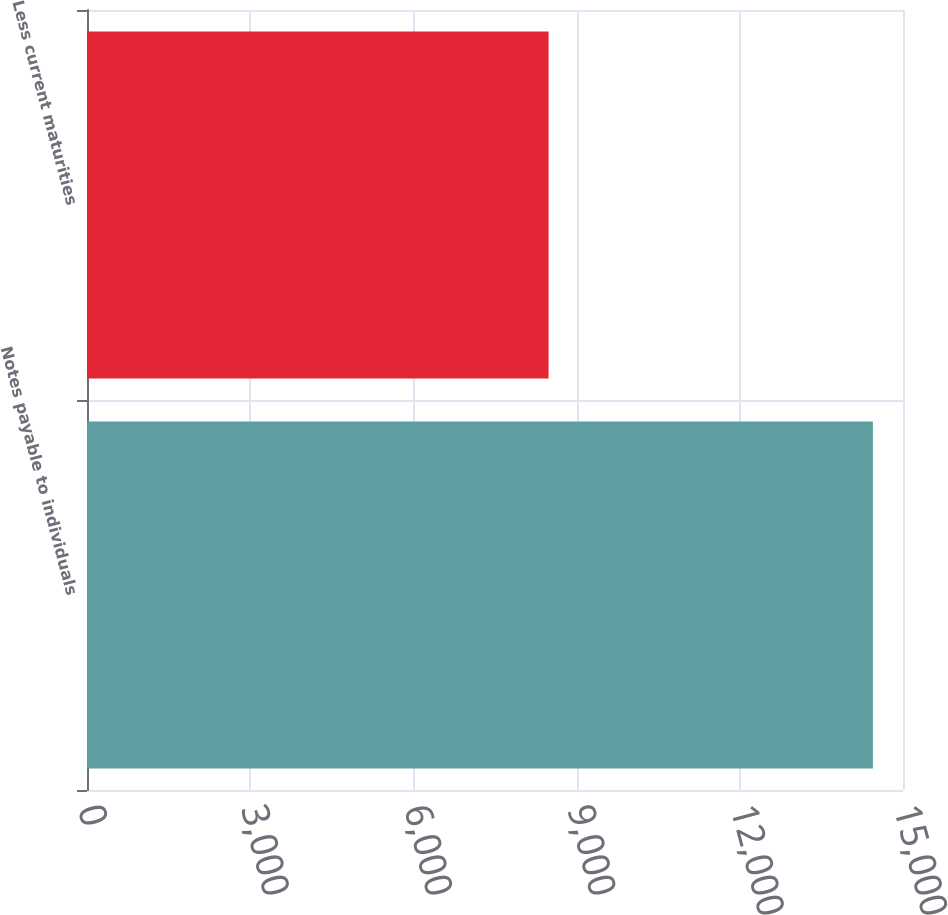Convert chart to OTSL. <chart><loc_0><loc_0><loc_500><loc_500><bar_chart><fcel>Notes payable to individuals<fcel>Less current maturities<nl><fcel>14447<fcel>8485<nl></chart> 